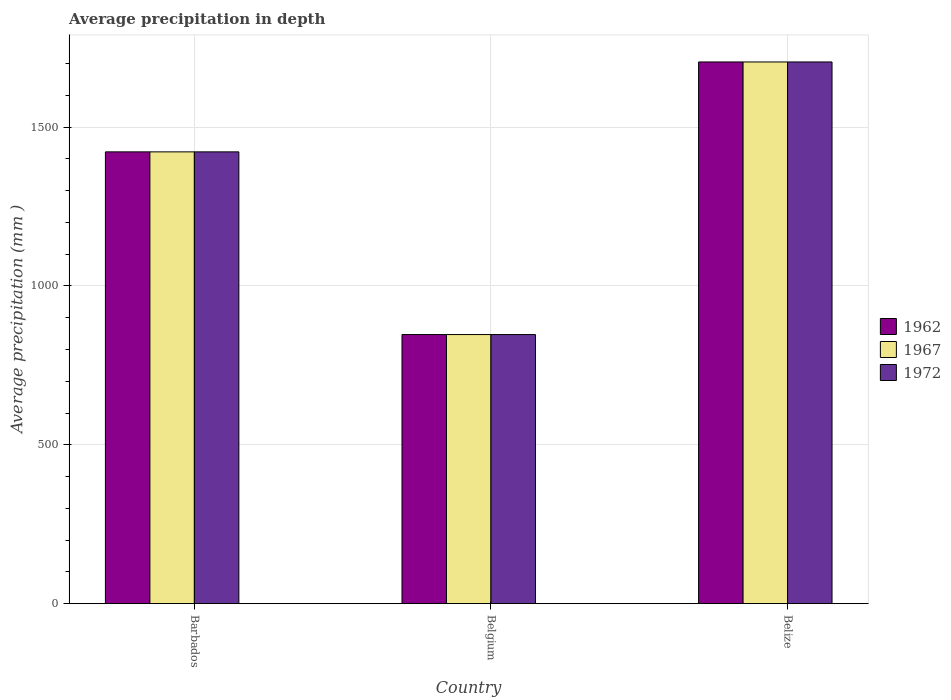How many bars are there on the 1st tick from the left?
Your response must be concise. 3. What is the label of the 3rd group of bars from the left?
Offer a very short reply. Belize. What is the average precipitation in 1967 in Barbados?
Make the answer very short. 1422. Across all countries, what is the maximum average precipitation in 1972?
Offer a very short reply. 1705. Across all countries, what is the minimum average precipitation in 1972?
Provide a succinct answer. 847. In which country was the average precipitation in 1972 maximum?
Make the answer very short. Belize. What is the total average precipitation in 1972 in the graph?
Offer a very short reply. 3974. What is the difference between the average precipitation in 1972 in Barbados and that in Belize?
Ensure brevity in your answer.  -283. What is the difference between the average precipitation in 1962 in Barbados and the average precipitation in 1972 in Belgium?
Ensure brevity in your answer.  575. What is the average average precipitation in 1962 per country?
Make the answer very short. 1324.67. What is the difference between the average precipitation of/in 1972 and average precipitation of/in 1967 in Belgium?
Your response must be concise. 0. In how many countries, is the average precipitation in 1962 greater than 1200 mm?
Ensure brevity in your answer.  2. What is the ratio of the average precipitation in 1962 in Barbados to that in Belgium?
Your response must be concise. 1.68. What is the difference between the highest and the second highest average precipitation in 1967?
Keep it short and to the point. 283. What is the difference between the highest and the lowest average precipitation in 1962?
Your answer should be very brief. 858. In how many countries, is the average precipitation in 1972 greater than the average average precipitation in 1972 taken over all countries?
Your response must be concise. 2. What does the 2nd bar from the left in Belize represents?
Your answer should be compact. 1967. What does the 1st bar from the right in Belgium represents?
Provide a succinct answer. 1972. How many bars are there?
Your answer should be compact. 9. How many legend labels are there?
Ensure brevity in your answer.  3. How are the legend labels stacked?
Offer a terse response. Vertical. What is the title of the graph?
Offer a very short reply. Average precipitation in depth. What is the label or title of the Y-axis?
Your answer should be very brief. Average precipitation (mm ). What is the Average precipitation (mm ) of 1962 in Barbados?
Your answer should be very brief. 1422. What is the Average precipitation (mm ) in 1967 in Barbados?
Provide a succinct answer. 1422. What is the Average precipitation (mm ) of 1972 in Barbados?
Provide a short and direct response. 1422. What is the Average precipitation (mm ) in 1962 in Belgium?
Give a very brief answer. 847. What is the Average precipitation (mm ) of 1967 in Belgium?
Make the answer very short. 847. What is the Average precipitation (mm ) in 1972 in Belgium?
Provide a short and direct response. 847. What is the Average precipitation (mm ) in 1962 in Belize?
Give a very brief answer. 1705. What is the Average precipitation (mm ) in 1967 in Belize?
Provide a succinct answer. 1705. What is the Average precipitation (mm ) in 1972 in Belize?
Offer a terse response. 1705. Across all countries, what is the maximum Average precipitation (mm ) in 1962?
Ensure brevity in your answer.  1705. Across all countries, what is the maximum Average precipitation (mm ) in 1967?
Provide a succinct answer. 1705. Across all countries, what is the maximum Average precipitation (mm ) of 1972?
Your answer should be very brief. 1705. Across all countries, what is the minimum Average precipitation (mm ) in 1962?
Your answer should be compact. 847. Across all countries, what is the minimum Average precipitation (mm ) in 1967?
Offer a very short reply. 847. Across all countries, what is the minimum Average precipitation (mm ) of 1972?
Offer a terse response. 847. What is the total Average precipitation (mm ) of 1962 in the graph?
Ensure brevity in your answer.  3974. What is the total Average precipitation (mm ) of 1967 in the graph?
Your answer should be compact. 3974. What is the total Average precipitation (mm ) of 1972 in the graph?
Keep it short and to the point. 3974. What is the difference between the Average precipitation (mm ) of 1962 in Barbados and that in Belgium?
Your answer should be compact. 575. What is the difference between the Average precipitation (mm ) in 1967 in Barbados and that in Belgium?
Your answer should be compact. 575. What is the difference between the Average precipitation (mm ) of 1972 in Barbados and that in Belgium?
Give a very brief answer. 575. What is the difference between the Average precipitation (mm ) in 1962 in Barbados and that in Belize?
Your answer should be very brief. -283. What is the difference between the Average precipitation (mm ) in 1967 in Barbados and that in Belize?
Ensure brevity in your answer.  -283. What is the difference between the Average precipitation (mm ) of 1972 in Barbados and that in Belize?
Your answer should be compact. -283. What is the difference between the Average precipitation (mm ) in 1962 in Belgium and that in Belize?
Keep it short and to the point. -858. What is the difference between the Average precipitation (mm ) in 1967 in Belgium and that in Belize?
Offer a terse response. -858. What is the difference between the Average precipitation (mm ) in 1972 in Belgium and that in Belize?
Your response must be concise. -858. What is the difference between the Average precipitation (mm ) of 1962 in Barbados and the Average precipitation (mm ) of 1967 in Belgium?
Keep it short and to the point. 575. What is the difference between the Average precipitation (mm ) of 1962 in Barbados and the Average precipitation (mm ) of 1972 in Belgium?
Make the answer very short. 575. What is the difference between the Average precipitation (mm ) of 1967 in Barbados and the Average precipitation (mm ) of 1972 in Belgium?
Your answer should be very brief. 575. What is the difference between the Average precipitation (mm ) of 1962 in Barbados and the Average precipitation (mm ) of 1967 in Belize?
Your answer should be very brief. -283. What is the difference between the Average precipitation (mm ) in 1962 in Barbados and the Average precipitation (mm ) in 1972 in Belize?
Make the answer very short. -283. What is the difference between the Average precipitation (mm ) of 1967 in Barbados and the Average precipitation (mm ) of 1972 in Belize?
Offer a very short reply. -283. What is the difference between the Average precipitation (mm ) of 1962 in Belgium and the Average precipitation (mm ) of 1967 in Belize?
Your answer should be very brief. -858. What is the difference between the Average precipitation (mm ) in 1962 in Belgium and the Average precipitation (mm ) in 1972 in Belize?
Make the answer very short. -858. What is the difference between the Average precipitation (mm ) in 1967 in Belgium and the Average precipitation (mm ) in 1972 in Belize?
Make the answer very short. -858. What is the average Average precipitation (mm ) of 1962 per country?
Offer a very short reply. 1324.67. What is the average Average precipitation (mm ) in 1967 per country?
Give a very brief answer. 1324.67. What is the average Average precipitation (mm ) in 1972 per country?
Give a very brief answer. 1324.67. What is the difference between the Average precipitation (mm ) of 1962 and Average precipitation (mm ) of 1967 in Barbados?
Ensure brevity in your answer.  0. What is the difference between the Average precipitation (mm ) in 1962 and Average precipitation (mm ) in 1972 in Barbados?
Your answer should be compact. 0. What is the difference between the Average precipitation (mm ) of 1967 and Average precipitation (mm ) of 1972 in Barbados?
Offer a very short reply. 0. What is the difference between the Average precipitation (mm ) of 1967 and Average precipitation (mm ) of 1972 in Belgium?
Keep it short and to the point. 0. What is the difference between the Average precipitation (mm ) in 1962 and Average precipitation (mm ) in 1972 in Belize?
Offer a very short reply. 0. What is the difference between the Average precipitation (mm ) of 1967 and Average precipitation (mm ) of 1972 in Belize?
Provide a succinct answer. 0. What is the ratio of the Average precipitation (mm ) in 1962 in Barbados to that in Belgium?
Keep it short and to the point. 1.68. What is the ratio of the Average precipitation (mm ) of 1967 in Barbados to that in Belgium?
Provide a succinct answer. 1.68. What is the ratio of the Average precipitation (mm ) in 1972 in Barbados to that in Belgium?
Make the answer very short. 1.68. What is the ratio of the Average precipitation (mm ) in 1962 in Barbados to that in Belize?
Provide a short and direct response. 0.83. What is the ratio of the Average precipitation (mm ) in 1967 in Barbados to that in Belize?
Provide a succinct answer. 0.83. What is the ratio of the Average precipitation (mm ) of 1972 in Barbados to that in Belize?
Keep it short and to the point. 0.83. What is the ratio of the Average precipitation (mm ) of 1962 in Belgium to that in Belize?
Give a very brief answer. 0.5. What is the ratio of the Average precipitation (mm ) in 1967 in Belgium to that in Belize?
Offer a very short reply. 0.5. What is the ratio of the Average precipitation (mm ) of 1972 in Belgium to that in Belize?
Your response must be concise. 0.5. What is the difference between the highest and the second highest Average precipitation (mm ) of 1962?
Make the answer very short. 283. What is the difference between the highest and the second highest Average precipitation (mm ) of 1967?
Provide a succinct answer. 283. What is the difference between the highest and the second highest Average precipitation (mm ) of 1972?
Make the answer very short. 283. What is the difference between the highest and the lowest Average precipitation (mm ) in 1962?
Keep it short and to the point. 858. What is the difference between the highest and the lowest Average precipitation (mm ) in 1967?
Keep it short and to the point. 858. What is the difference between the highest and the lowest Average precipitation (mm ) in 1972?
Offer a terse response. 858. 